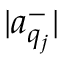Convert formula to latex. <formula><loc_0><loc_0><loc_500><loc_500>| a _ { q _ { j } } ^ { - } |</formula> 